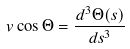Convert formula to latex. <formula><loc_0><loc_0><loc_500><loc_500>v \cos \Theta = \frac { d ^ { 3 } \Theta ( s ) } { d s ^ { 3 } }</formula> 